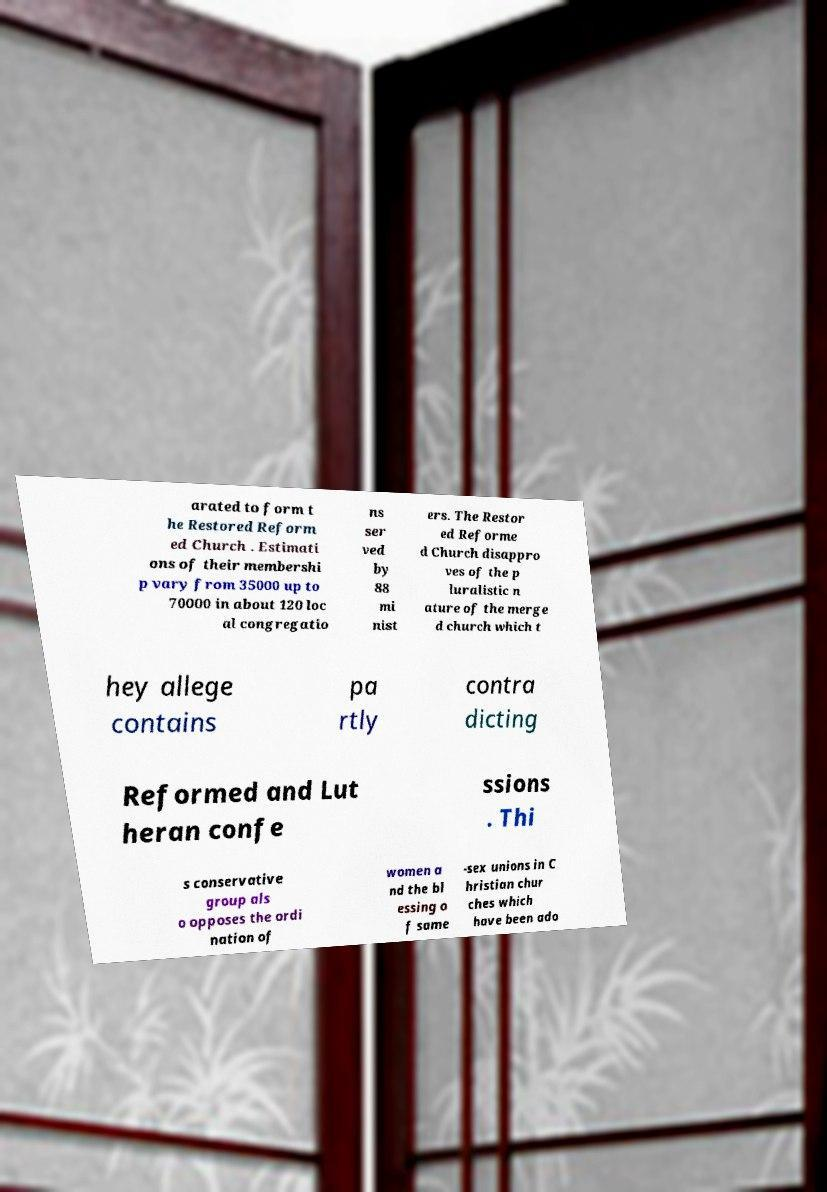Could you extract and type out the text from this image? arated to form t he Restored Reform ed Church . Estimati ons of their membershi p vary from 35000 up to 70000 in about 120 loc al congregatio ns ser ved by 88 mi nist ers. The Restor ed Reforme d Church disappro ves of the p luralistic n ature of the merge d church which t hey allege contains pa rtly contra dicting Reformed and Lut heran confe ssions . Thi s conservative group als o opposes the ordi nation of women a nd the bl essing o f same -sex unions in C hristian chur ches which have been ado 